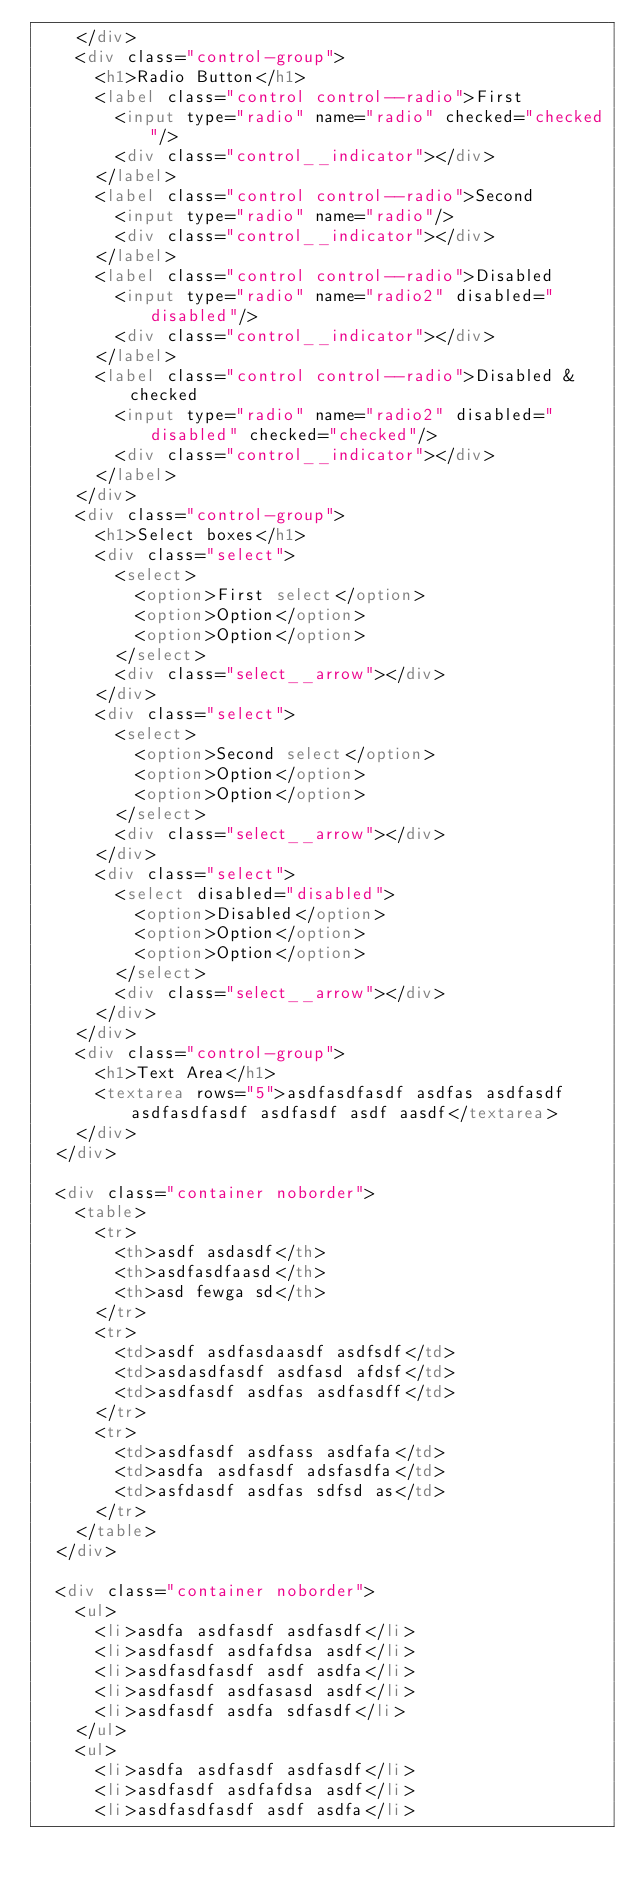Convert code to text. <code><loc_0><loc_0><loc_500><loc_500><_HTML_>    </div>
    <div class="control-group">
      <h1>Radio Button</h1>
      <label class="control control--radio">First
        <input type="radio" name="radio" checked="checked"/>
        <div class="control__indicator"></div>
      </label>
      <label class="control control--radio">Second
        <input type="radio" name="radio"/>
        <div class="control__indicator"></div>
      </label>
      <label class="control control--radio">Disabled
        <input type="radio" name="radio2" disabled="disabled"/>
        <div class="control__indicator"></div>
      </label>
      <label class="control control--radio">Disabled & checked
        <input type="radio" name="radio2" disabled="disabled" checked="checked"/>
        <div class="control__indicator"></div>
      </label>
    </div>
    <div class="control-group">
      <h1>Select boxes</h1>
      <div class="select">
        <select>
          <option>First select</option>
          <option>Option</option>
          <option>Option</option>
        </select>
        <div class="select__arrow"></div>
      </div>
      <div class="select">
        <select>
          <option>Second select</option>
          <option>Option</option>
          <option>Option</option>
        </select>
        <div class="select__arrow"></div>
      </div>
      <div class="select">
        <select disabled="disabled">
          <option>Disabled</option>
          <option>Option</option>
          <option>Option</option>
        </select>
        <div class="select__arrow"></div>
      </div>
    </div>
    <div class="control-group">
      <h1>Text Area</h1>
      <textarea rows="5">asdfasdfasdf asdfas asdfasdf asdfasdfasdf asdfasdf asdf aasdf</textarea>
    </div>
  </div>

  <div class="container noborder">
    <table>
      <tr>
        <th>asdf asdasdf</th>
        <th>asdfasdfaasd</th>
        <th>asd fewga sd</th>
      </tr>
      <tr>
        <td>asdf asdfasdaasdf asdfsdf</td>
        <td>asdasdfasdf asdfasd afdsf</td>
        <td>asdfasdf asdfas asdfasdff</td>
      </tr>
      <tr>
        <td>asdfasdf asdfass asdfafa</td>
        <td>asdfa asdfasdf adsfasdfa</td>
        <td>asfdasdf asdfas sdfsd as</td>
      </tr>
    </table>
  </div>

  <div class="container noborder">
    <ul>
      <li>asdfa asdfasdf asdfasdf</li>
      <li>asdfasdf asdfafdsa asdf</li>
      <li>asdfasdfasdf asdf asdfa</li>
      <li>asdfasdf asdfasasd asdf</li>
      <li>asdfasdf asdfa sdfasdf</li>
    </ul>
    <ul>
      <li>asdfa asdfasdf asdfasdf</li>
      <li>asdfasdf asdfafdsa asdf</li>
      <li>asdfasdfasdf asdf asdfa</li></code> 